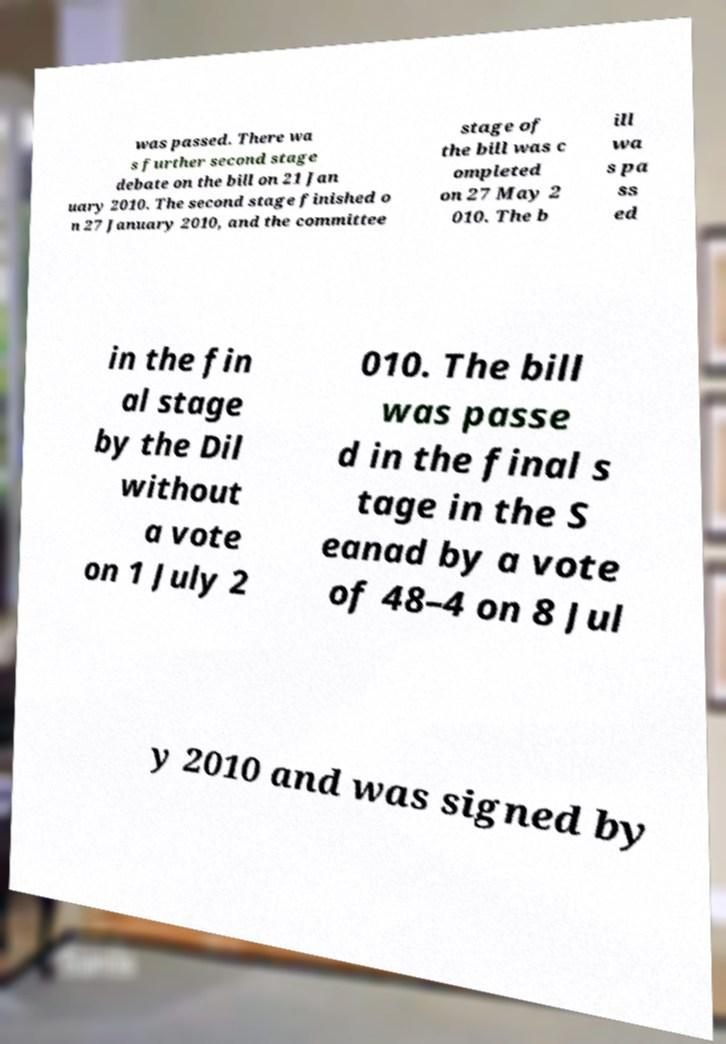I need the written content from this picture converted into text. Can you do that? was passed. There wa s further second stage debate on the bill on 21 Jan uary 2010. The second stage finished o n 27 January 2010, and the committee stage of the bill was c ompleted on 27 May 2 010. The b ill wa s pa ss ed in the fin al stage by the Dil without a vote on 1 July 2 010. The bill was passe d in the final s tage in the S eanad by a vote of 48–4 on 8 Jul y 2010 and was signed by 